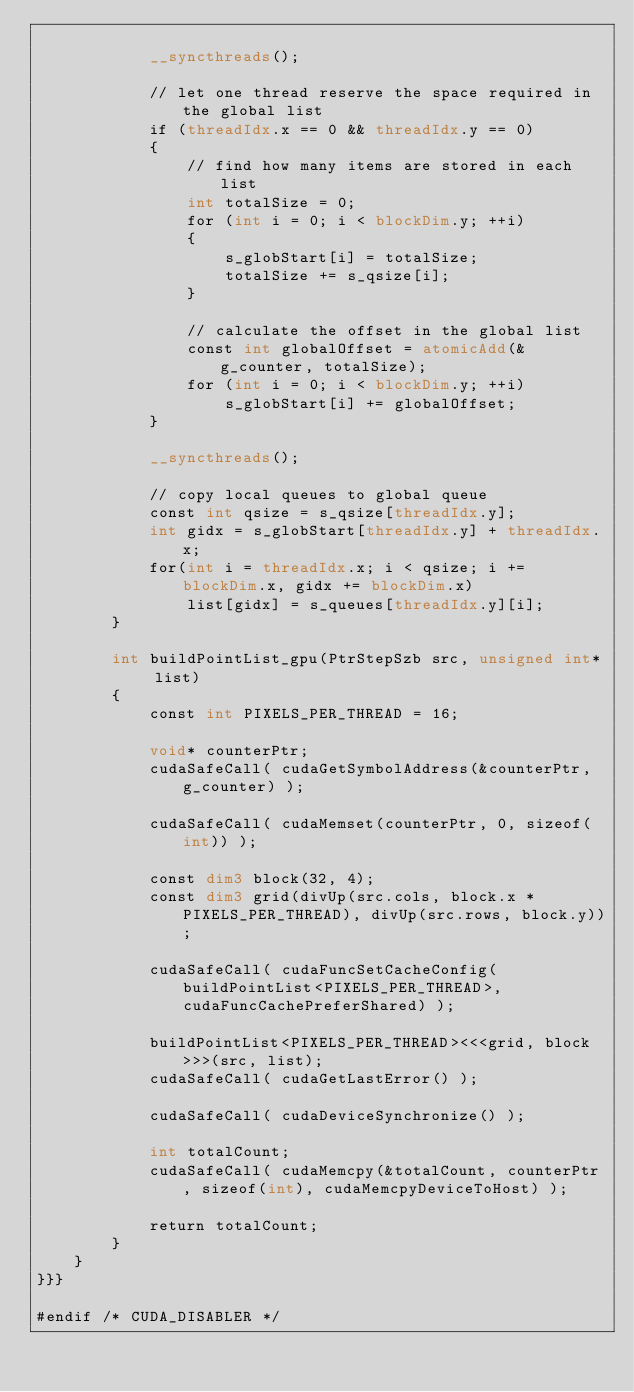Convert code to text. <code><loc_0><loc_0><loc_500><loc_500><_Cuda_>
            __syncthreads();

            // let one thread reserve the space required in the global list
            if (threadIdx.x == 0 && threadIdx.y == 0)
            {
                // find how many items are stored in each list
                int totalSize = 0;
                for (int i = 0; i < blockDim.y; ++i)
                {
                    s_globStart[i] = totalSize;
                    totalSize += s_qsize[i];
                }

                // calculate the offset in the global list
                const int globalOffset = atomicAdd(&g_counter, totalSize);
                for (int i = 0; i < blockDim.y; ++i)
                    s_globStart[i] += globalOffset;
            }

            __syncthreads();

            // copy local queues to global queue
            const int qsize = s_qsize[threadIdx.y];
            int gidx = s_globStart[threadIdx.y] + threadIdx.x;
            for(int i = threadIdx.x; i < qsize; i += blockDim.x, gidx += blockDim.x)
                list[gidx] = s_queues[threadIdx.y][i];
        }

        int buildPointList_gpu(PtrStepSzb src, unsigned int* list)
        {
            const int PIXELS_PER_THREAD = 16;

            void* counterPtr;
            cudaSafeCall( cudaGetSymbolAddress(&counterPtr, g_counter) );

            cudaSafeCall( cudaMemset(counterPtr, 0, sizeof(int)) );

            const dim3 block(32, 4);
            const dim3 grid(divUp(src.cols, block.x * PIXELS_PER_THREAD), divUp(src.rows, block.y));

            cudaSafeCall( cudaFuncSetCacheConfig(buildPointList<PIXELS_PER_THREAD>, cudaFuncCachePreferShared) );

            buildPointList<PIXELS_PER_THREAD><<<grid, block>>>(src, list);
            cudaSafeCall( cudaGetLastError() );

            cudaSafeCall( cudaDeviceSynchronize() );

            int totalCount;
            cudaSafeCall( cudaMemcpy(&totalCount, counterPtr, sizeof(int), cudaMemcpyDeviceToHost) );

            return totalCount;
        }
    }
}}}

#endif /* CUDA_DISABLER */
</code> 